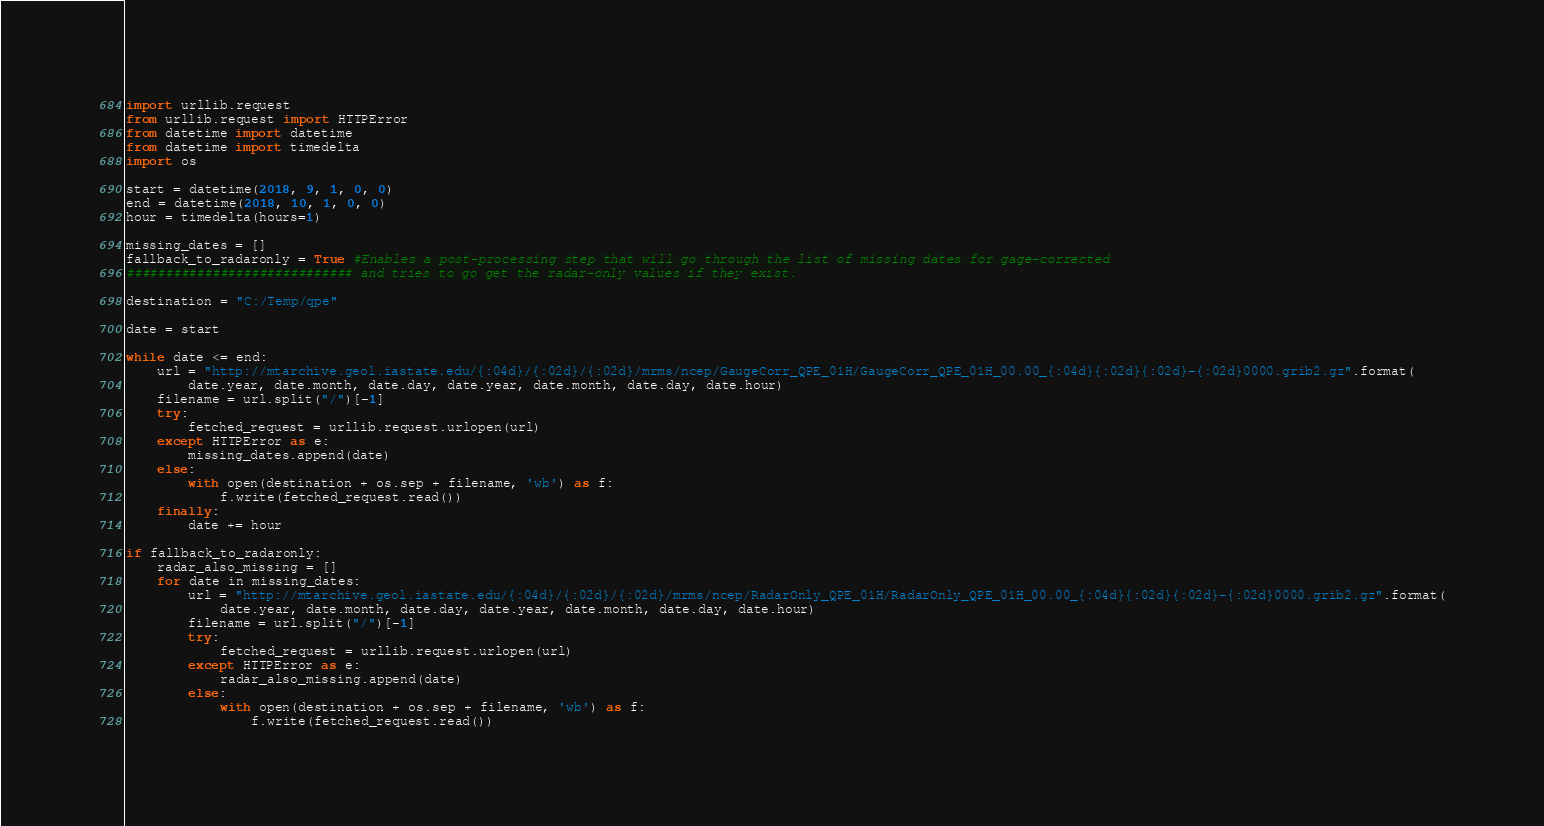<code> <loc_0><loc_0><loc_500><loc_500><_Python_>import urllib.request
from urllib.request import HTTPError
from datetime import datetime
from datetime import timedelta
import os

start = datetime(2018, 9, 1, 0, 0)
end = datetime(2018, 10, 1, 0, 0)
hour = timedelta(hours=1)

missing_dates = []
fallback_to_radaronly = True #Enables a post-processing step that will go through the list of missing dates for gage-corrected
############################# and tries to go get the radar-only values if they exist.

destination = "C:/Temp/qpe"

date = start

while date <= end:
    url = "http://mtarchive.geol.iastate.edu/{:04d}/{:02d}/{:02d}/mrms/ncep/GaugeCorr_QPE_01H/GaugeCorr_QPE_01H_00.00_{:04d}{:02d}{:02d}-{:02d}0000.grib2.gz".format(
        date.year, date.month, date.day, date.year, date.month, date.day, date.hour)
    filename = url.split("/")[-1]
    try:
        fetched_request = urllib.request.urlopen(url)
    except HTTPError as e:
        missing_dates.append(date)
    else:
        with open(destination + os.sep + filename, 'wb') as f:
            f.write(fetched_request.read())
    finally:
        date += hour

if fallback_to_radaronly:
    radar_also_missing = []
    for date in missing_dates:
        url = "http://mtarchive.geol.iastate.edu/{:04d}/{:02d}/{:02d}/mrms/ncep/RadarOnly_QPE_01H/RadarOnly_QPE_01H_00.00_{:04d}{:02d}{:02d}-{:02d}0000.grib2.gz".format(
            date.year, date.month, date.day, date.year, date.month, date.day, date.hour)
        filename = url.split("/")[-1]
        try:
            fetched_request = urllib.request.urlopen(url)
        except HTTPError as e:
            radar_also_missing.append(date)
        else:
            with open(destination + os.sep + filename, 'wb') as f:
                f.write(fetched_request.read())
</code> 